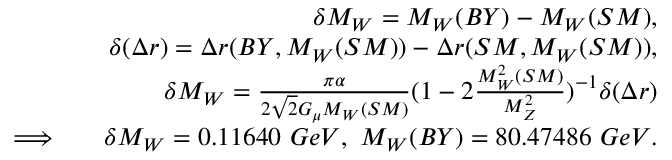<formula> <loc_0><loc_0><loc_500><loc_500>\begin{array} { r l r } & { \delta M _ { W } = M _ { W } ( B Y ) - M _ { W } ( S M ) , } \\ & { \delta ( \Delta r ) = \Delta r ( B Y , M _ { W } ( S M ) ) - \Delta r ( S M , M _ { W } ( S M ) ) , } \\ & { \delta M _ { W } = \frac { \pi \alpha } { 2 \sqrt { 2 } G _ { \mu } M _ { W } ( S M ) } ( 1 - 2 \frac { M _ { W } ^ { 2 } ( S M ) } { M _ { Z } ^ { 2 } } ) ^ { - 1 } \delta ( \Delta r ) } \\ { \Longrightarrow } & { \delta M _ { W } = 0 . 1 1 6 4 0 \ G e V , \ M _ { W } ( B Y ) = 8 0 . 4 7 4 8 6 \ G e V . } \end{array}</formula> 